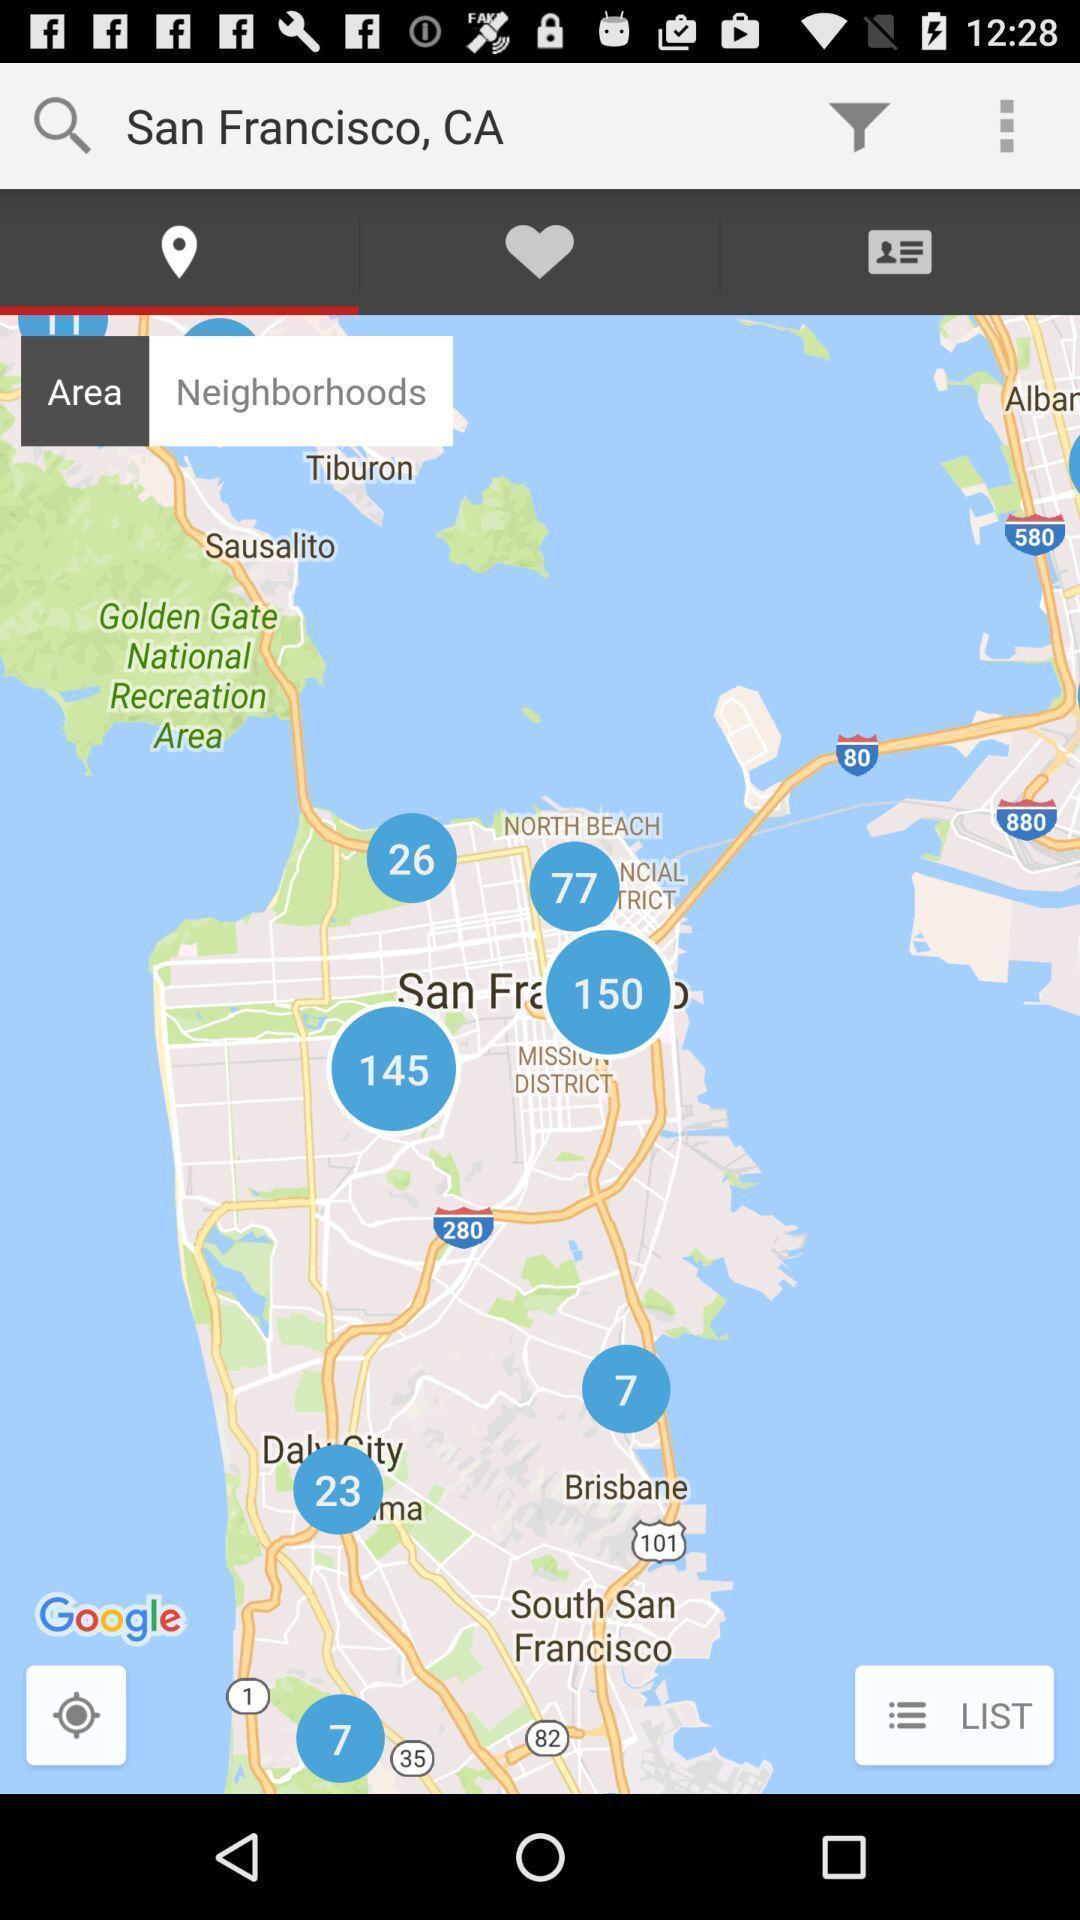Tell me what you see in this picture. Screen shows location on an app. 